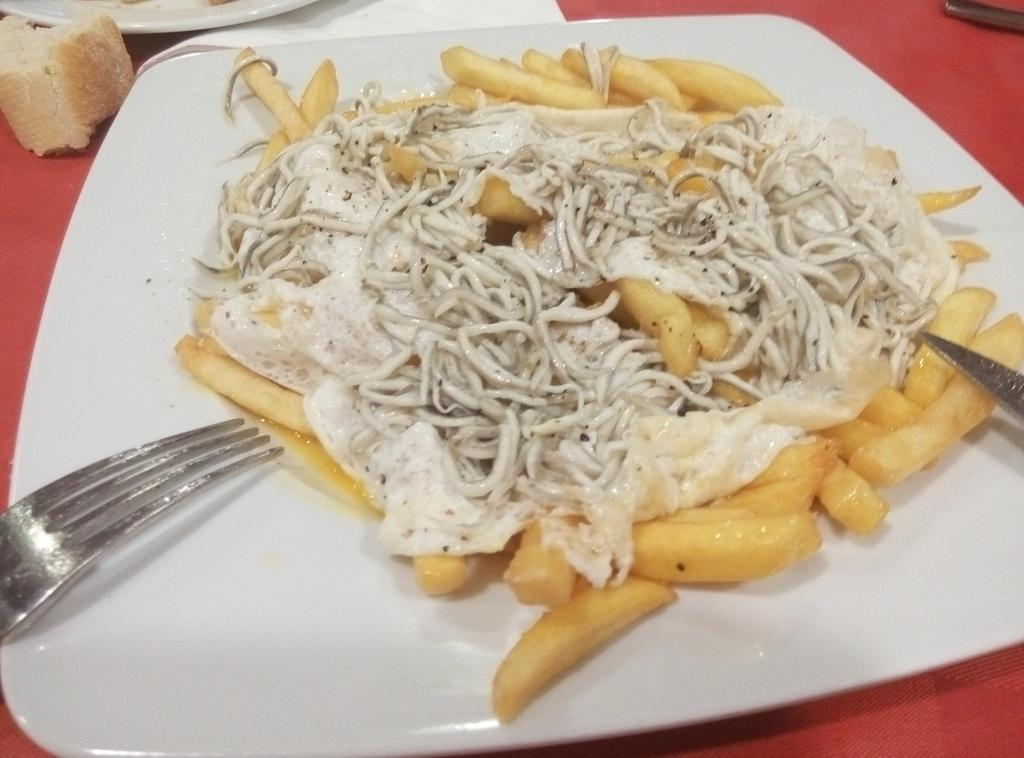What is the color of the surface in the image? The surface in the image is red. How many plates are on the surface? There are 2 plates on the surface. What is the color of the food on the plates? The food on the plates is yellow and white in color. What utensil can be seen in the image? There is a fork visible in the image. What type of cannon is present on the red surface in the image? There is no cannon present on the red surface in the image. What type of skirt can be seen on the plates in the image? There are no skirts present on the plates in the image; the plates contain food. 